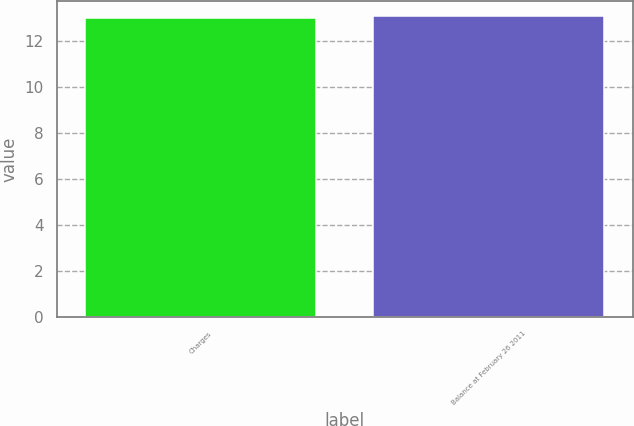Convert chart to OTSL. <chart><loc_0><loc_0><loc_500><loc_500><bar_chart><fcel>Charges<fcel>Balance at February 26 2011<nl><fcel>13<fcel>13.1<nl></chart> 